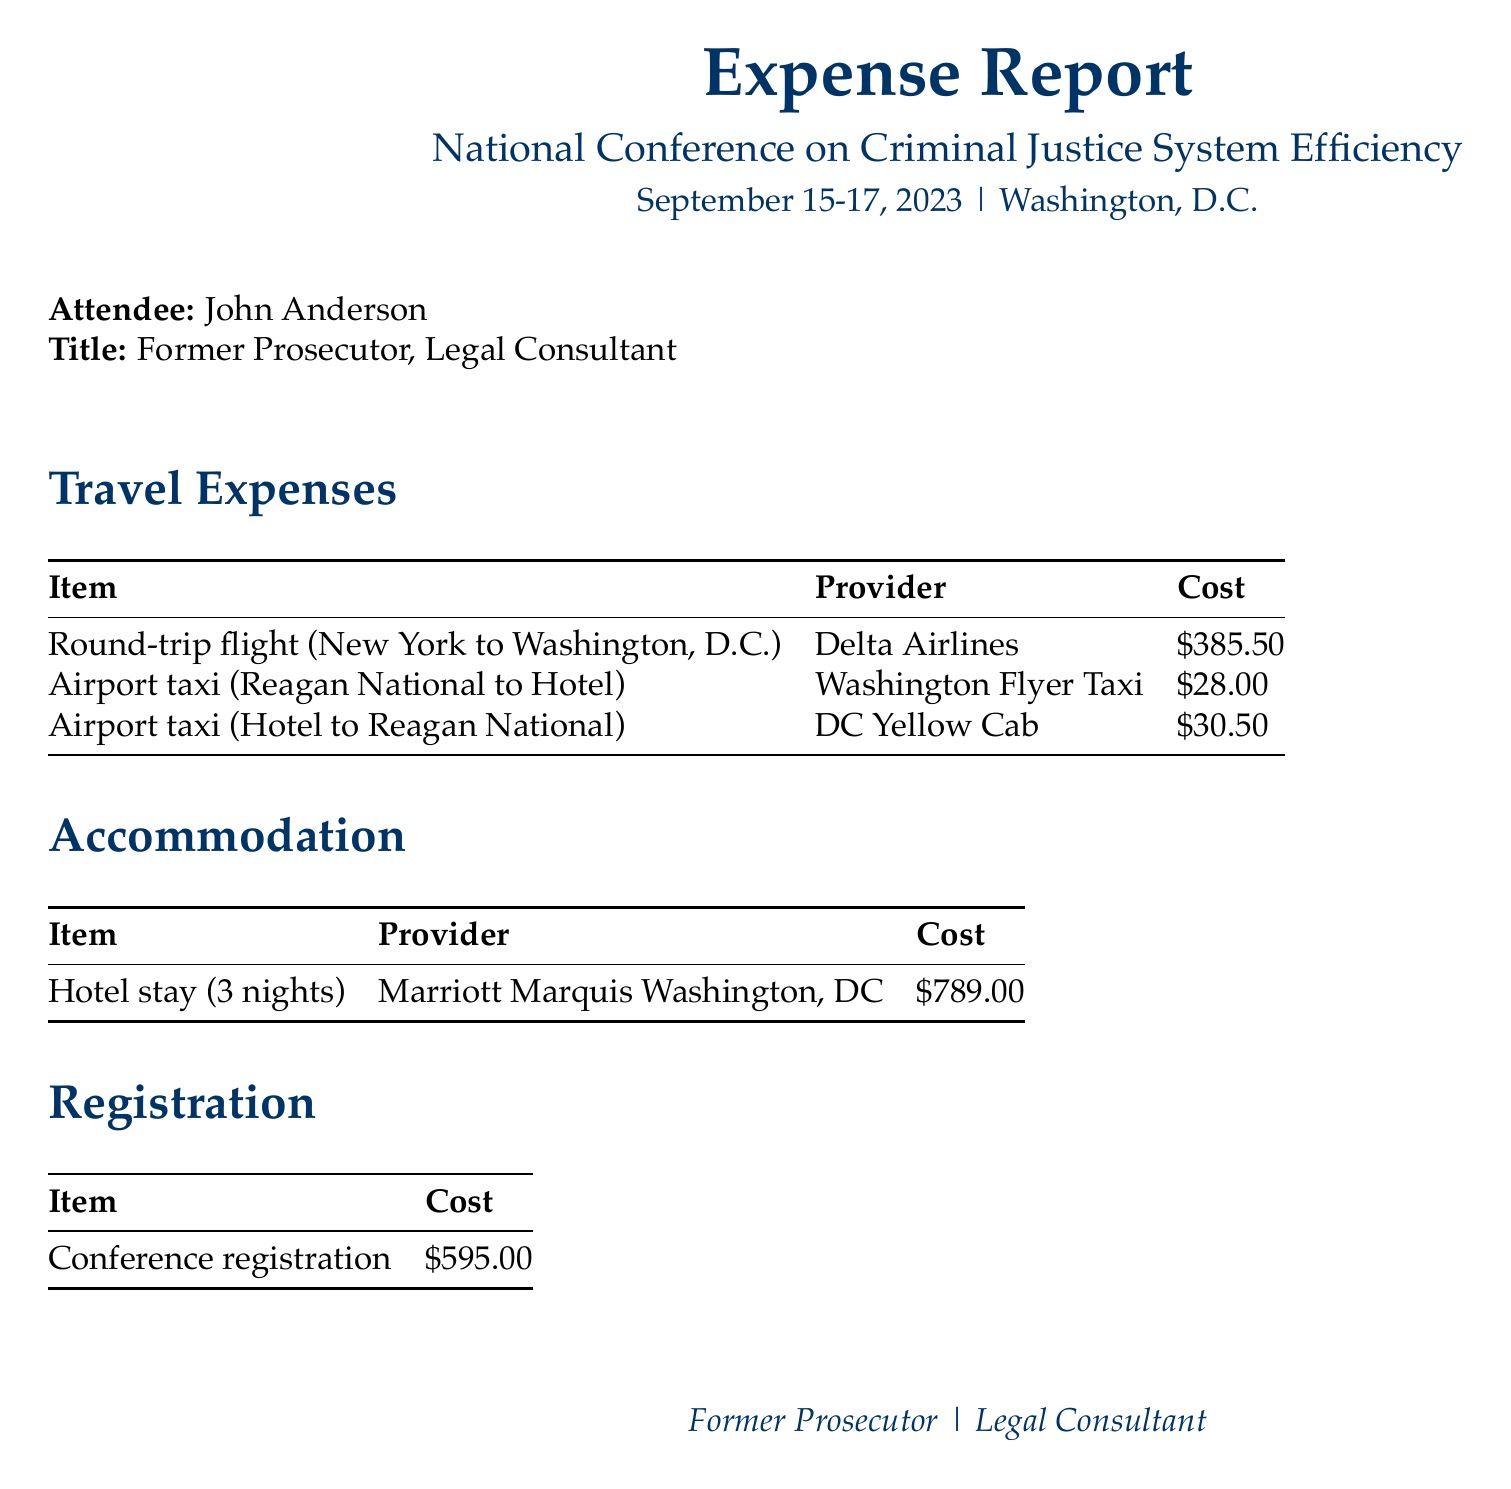What is the conference name? The conference name is stated prominently in the document, which is "National Conference on Criminal Justice System Efficiency."
Answer: National Conference on Criminal Justice System Efficiency Who organized the conference? The document specifies that the organizer of the conference is the "American Bar Association."
Answer: American Bar Association What were the total travel expenses? By summing all listed travel expenses, the total comes to $385.50 + $28.00 + $30.50 = $444.00.
Answer: $444.00 What is the cost of the hotel stay? The hotel stay cost is explicitly listed under accommodation expenses, which is $789.00 for 3 nights.
Answer: $789.00 How much was spent on meals? The meal expenses shown in the document total to $120.75 + $85.50 = $206.25.
Answer: $206.25 What is the total expenses amount? The document provides a summary of all expenses, culminating in a total of $2,154.25.
Answer: $2,154.25 How many nights was the hotel accommodation? The document indicates that the hotel stay covered 3 nights.
Answer: 3 nights What type of expense is printing materials classified under? The printing expense is categorized under "Miscellaneous Expenses" in the document.
Answer: Miscellaneous Expenses What was a notable activity attended at the conference? The document details the attendee's participation in key events, including a keynote speech by the Attorney General.
Answer: Keynote speech by Attorney General 